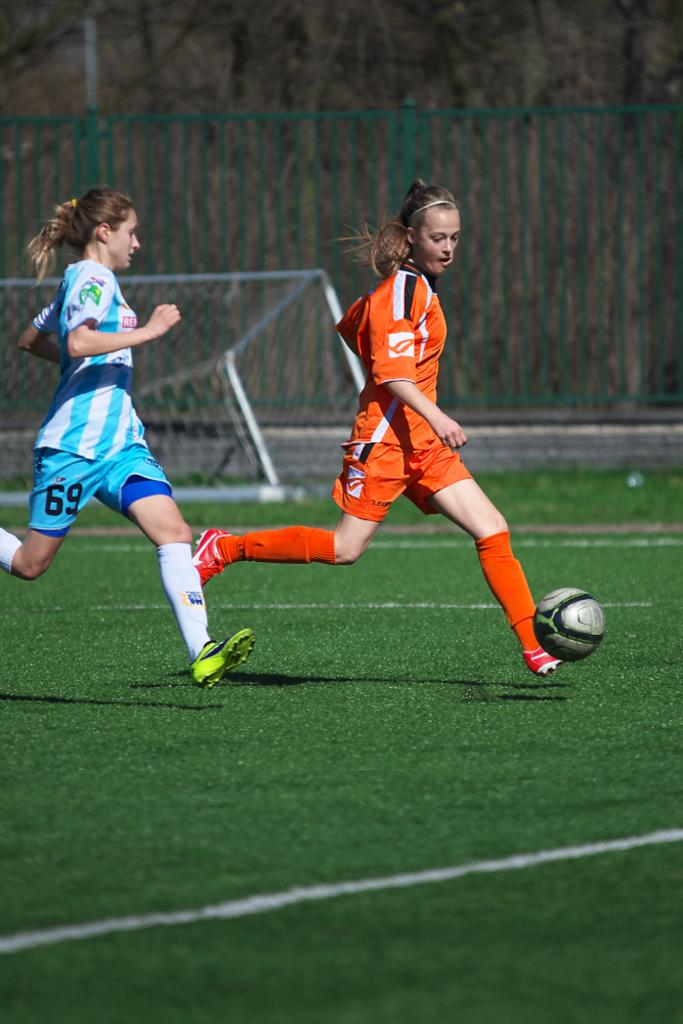Provide a one-sentence caption for the provided image. a couple of soccer players one with the number 69 on their pants. 